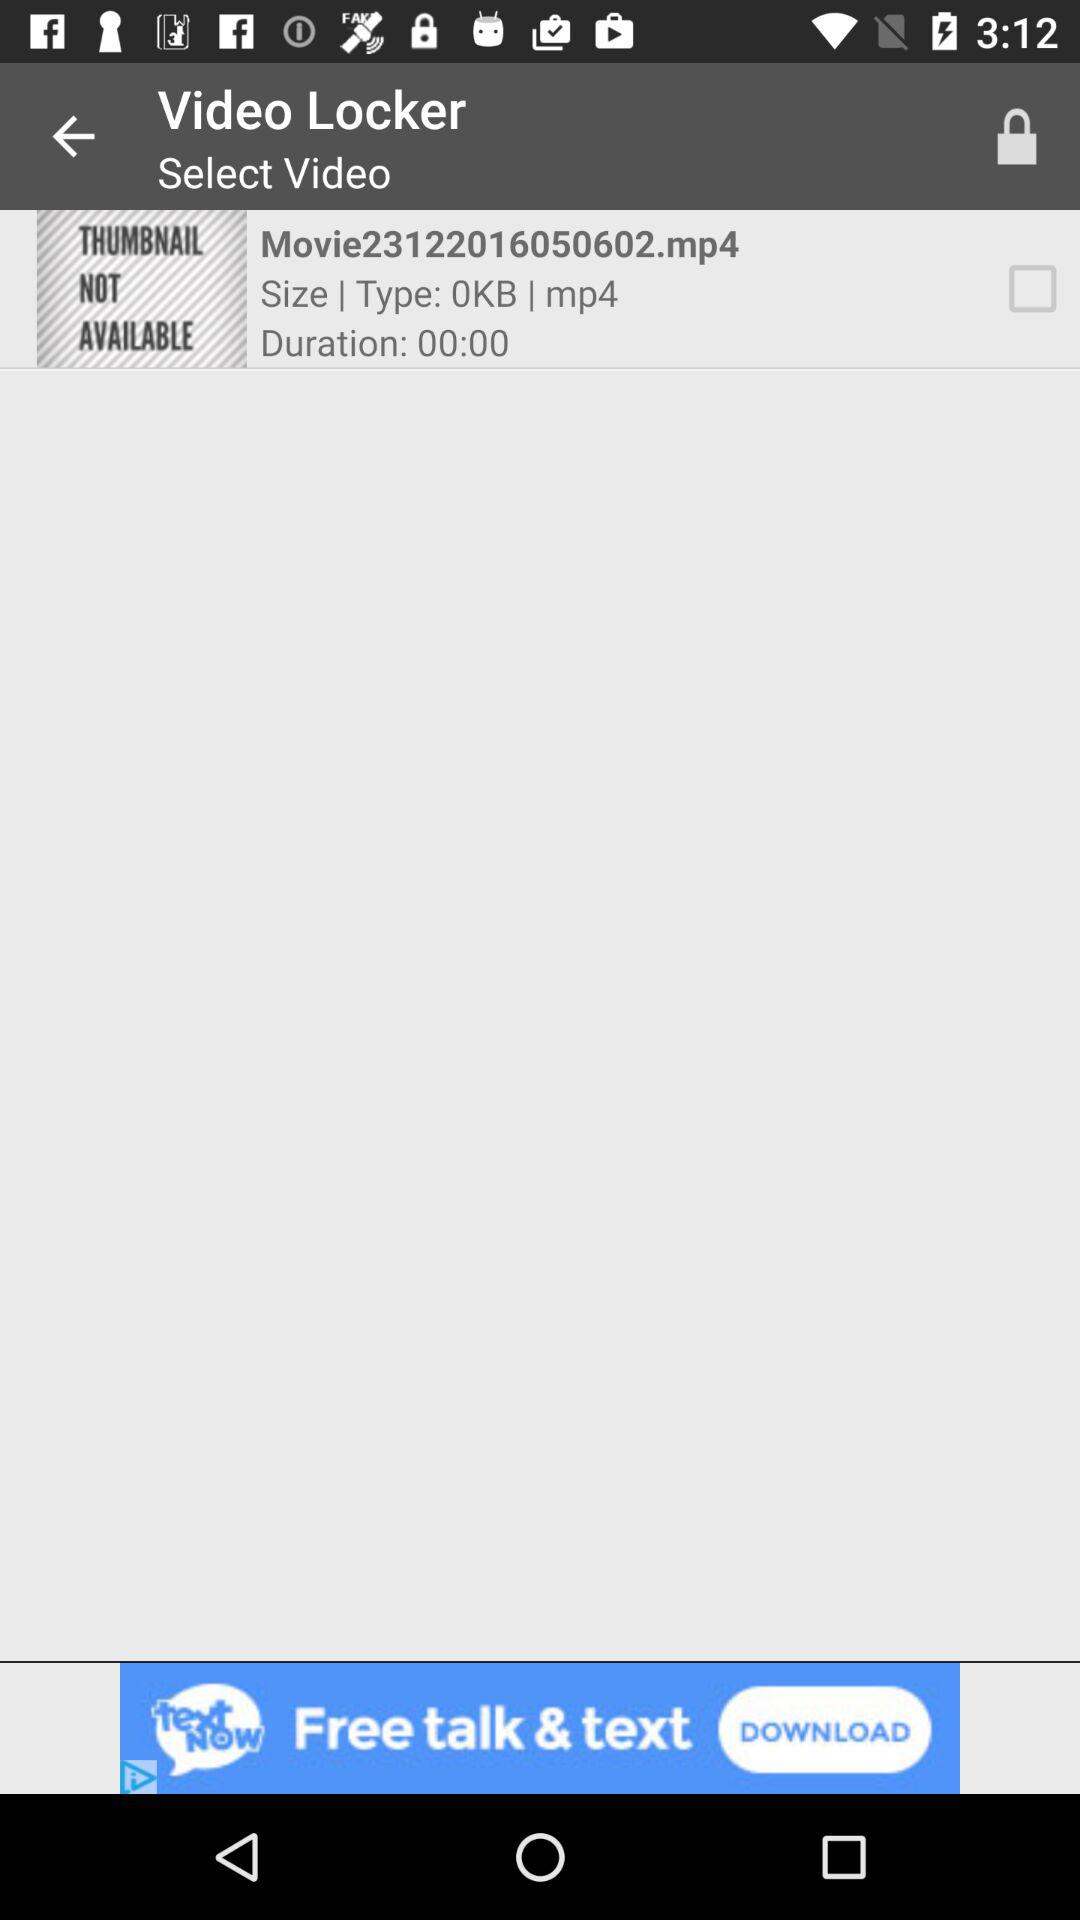What is the duration of the video? The duration of the video is 00:00. 